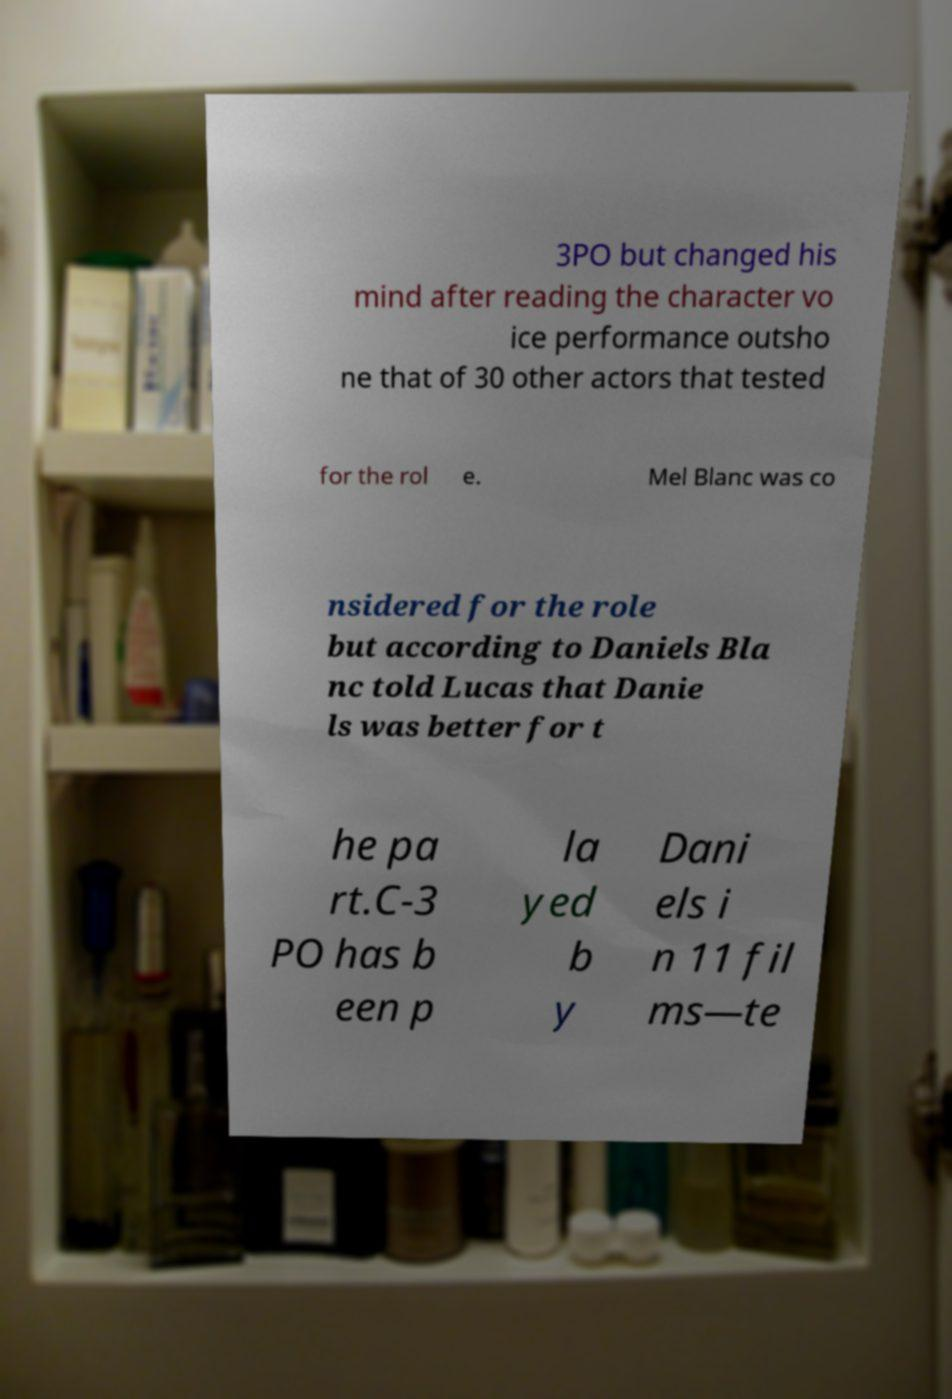Please identify and transcribe the text found in this image. 3PO but changed his mind after reading the character vo ice performance outsho ne that of 30 other actors that tested for the rol e. Mel Blanc was co nsidered for the role but according to Daniels Bla nc told Lucas that Danie ls was better for t he pa rt.C-3 PO has b een p la yed b y Dani els i n 11 fil ms—te 